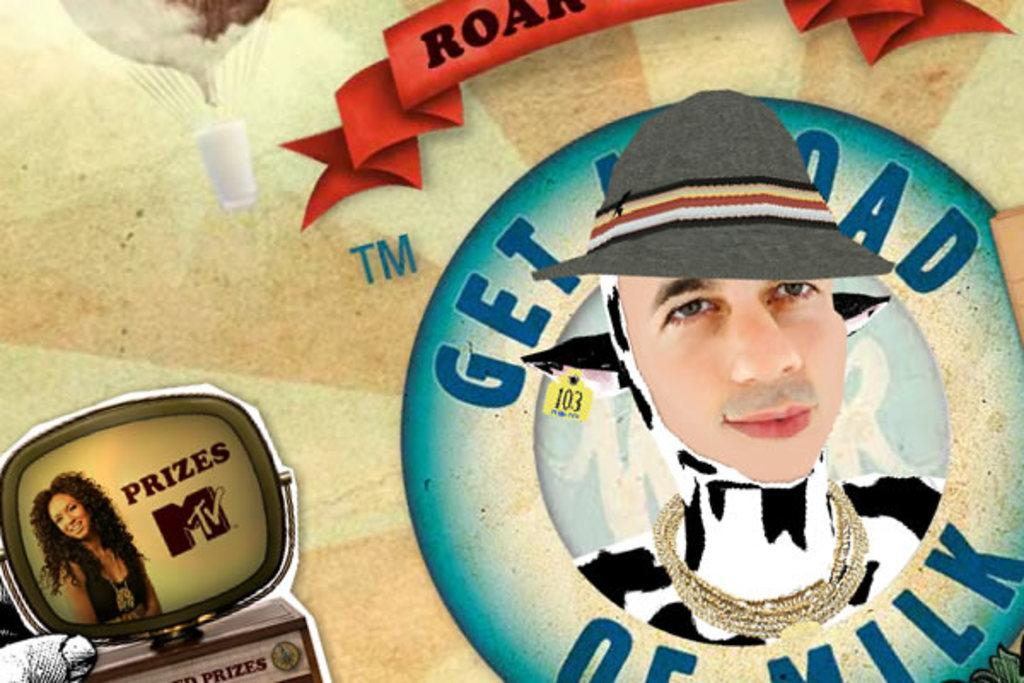What can be observed about the nature of the image? The image is edited. What is located on the right side of the image? There is a man's face with a hat on the right side of the image. What type of object is present at the bottom of the image? There is a cartoon TV at the bottom of the image. What can be seen inside the cartoon TV? Inside the cartoon TV, there is a woman. What type of love can be seen in the image? There is no love present in the image; it features a man's face with a hat, a cartoon TV, and a woman inside the TV. How many times has the image been copied? The number of times the image has been copied is not mentioned in the provided facts, and therefore cannot be determined. 